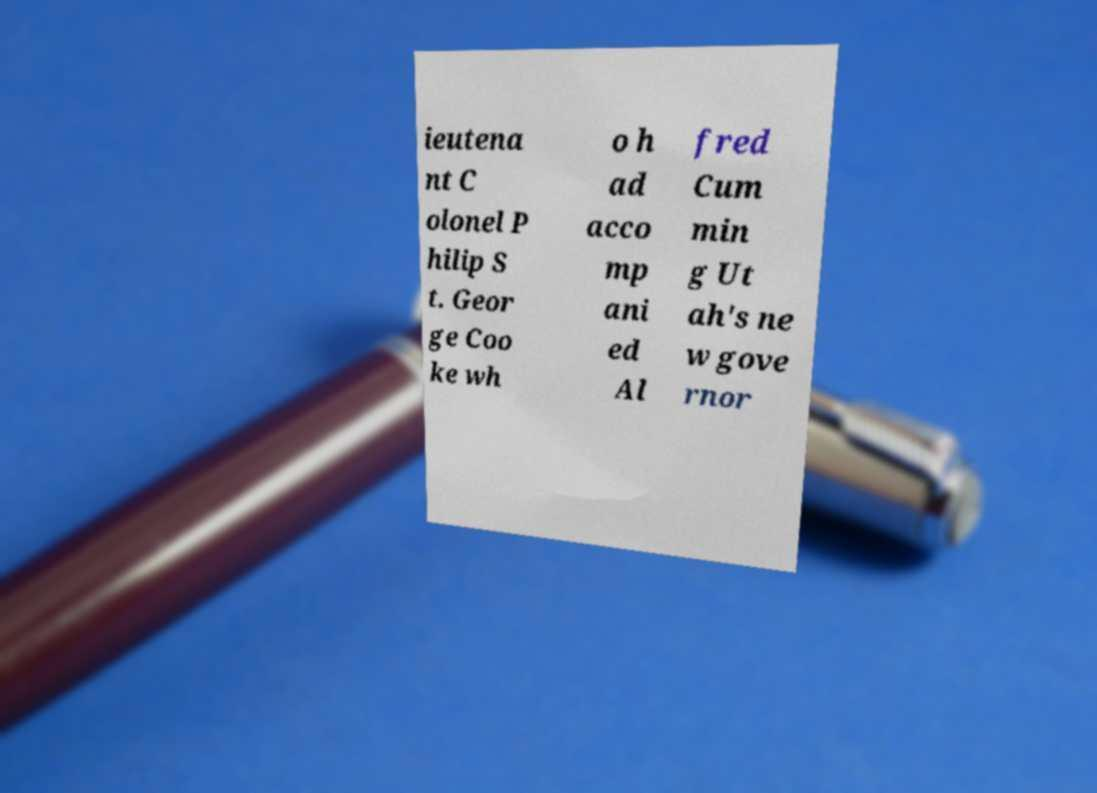Could you extract and type out the text from this image? ieutena nt C olonel P hilip S t. Geor ge Coo ke wh o h ad acco mp ani ed Al fred Cum min g Ut ah's ne w gove rnor 